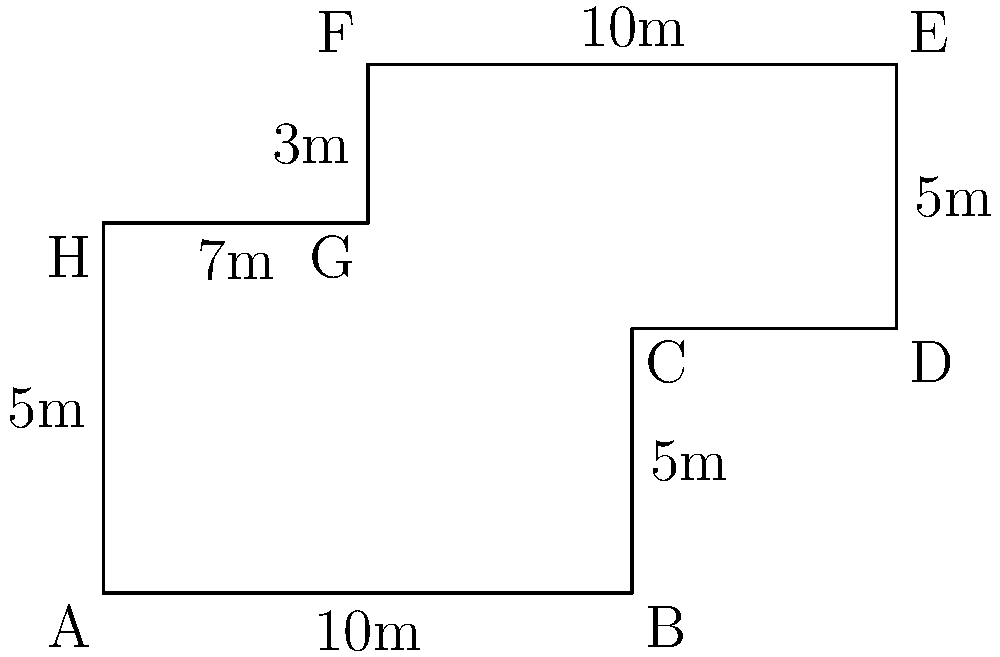As an insurance attorney, you're reviewing a case involving a commercial building with a complex floor plan. The building's layout is shown in the diagram above, where each square represents 1 meter. Calculate the perimeter of the building to determine the extent of potential exterior damage coverage. To calculate the perimeter, we need to sum up the lengths of all exterior sides of the building:

1) Side AB: $10$ meters
2) Side BC: $5$ meters
3) Side CD: $5$ meters
4) Side DE: $5$ meters
5) Side EF: $10$ meters
6) Side FG: $3$ meters
7) Side GH: $5$ meters
8) Side HA: $7$ meters

Total perimeter = $10 + 5 + 5 + 5 + 10 + 3 + 5 + 7 = 50$ meters

It's important to note that we don't include the interior line between G and C, as it's not part of the exterior perimeter.
Answer: $50$ meters 